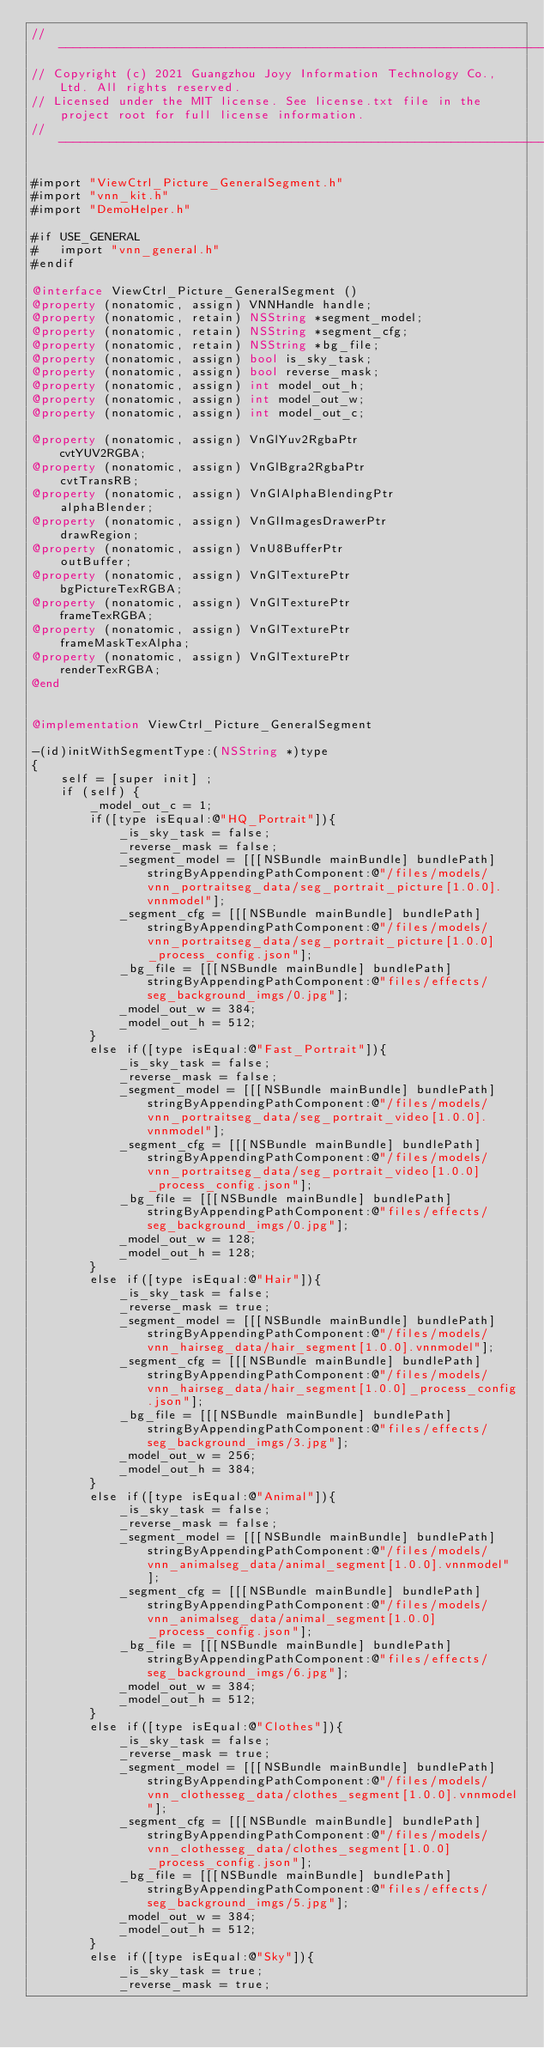<code> <loc_0><loc_0><loc_500><loc_500><_ObjectiveC_>//-------------------------------------------------------------------------------------------------------
// Copyright (c) 2021 Guangzhou Joyy Information Technology Co., Ltd. All rights reserved.
// Licensed under the MIT license. See license.txt file in the project root for full license information.
//-------------------------------------------------------------------------------------------------------

#import "ViewCtrl_Picture_GeneralSegment.h"
#import "vnn_kit.h"
#import "DemoHelper.h"

#if USE_GENERAL
#   import "vnn_general.h"
#endif

@interface ViewCtrl_Picture_GeneralSegment ()
@property (nonatomic, assign) VNNHandle handle;
@property (nonatomic, retain) NSString *segment_model;
@property (nonatomic, retain) NSString *segment_cfg;
@property (nonatomic, retain) NSString *bg_file;
@property (nonatomic, assign) bool is_sky_task;
@property (nonatomic, assign) bool reverse_mask;
@property (nonatomic, assign) int model_out_h;
@property (nonatomic, assign) int model_out_w;
@property (nonatomic, assign) int model_out_c;

@property (nonatomic, assign) VnGlYuv2RgbaPtr              cvtYUV2RGBA;
@property (nonatomic, assign) VnGlBgra2RgbaPtr             cvtTransRB;
@property (nonatomic, assign) VnGlAlphaBlendingPtr         alphaBlender;
@property (nonatomic, assign) VnGlImagesDrawerPtr          drawRegion;
@property (nonatomic, assign) VnU8BufferPtr                outBuffer;
@property (nonatomic, assign) VnGlTexturePtr               bgPictureTexRGBA;
@property (nonatomic, assign) VnGlTexturePtr               frameTexRGBA;
@property (nonatomic, assign) VnGlTexturePtr               frameMaskTexAlpha;
@property (nonatomic, assign) VnGlTexturePtr               renderTexRGBA;
@end


@implementation ViewCtrl_Picture_GeneralSegment

-(id)initWithSegmentType:(NSString *)type
{
    self = [super init] ;
    if (self) {
        _model_out_c = 1;
        if([type isEqual:@"HQ_Portrait"]){
            _is_sky_task = false;
            _reverse_mask = false;
            _segment_model = [[[NSBundle mainBundle] bundlePath] stringByAppendingPathComponent:@"/files/models/vnn_portraitseg_data/seg_portrait_picture[1.0.0].vnnmodel"];
            _segment_cfg = [[[NSBundle mainBundle] bundlePath] stringByAppendingPathComponent:@"/files/models/vnn_portraitseg_data/seg_portrait_picture[1.0.0]_process_config.json"];
            _bg_file = [[[NSBundle mainBundle] bundlePath] stringByAppendingPathComponent:@"files/effects/seg_background_imgs/0.jpg"];
            _model_out_w = 384;
            _model_out_h = 512;
        }
        else if([type isEqual:@"Fast_Portrait"]){
            _is_sky_task = false;
            _reverse_mask = false;
            _segment_model = [[[NSBundle mainBundle] bundlePath] stringByAppendingPathComponent:@"/files/models/vnn_portraitseg_data/seg_portrait_video[1.0.0].vnnmodel"];
            _segment_cfg = [[[NSBundle mainBundle] bundlePath] stringByAppendingPathComponent:@"/files/models/vnn_portraitseg_data/seg_portrait_video[1.0.0]_process_config.json"];
            _bg_file = [[[NSBundle mainBundle] bundlePath] stringByAppendingPathComponent:@"files/effects/seg_background_imgs/0.jpg"];
            _model_out_w = 128;
            _model_out_h = 128;
        }
        else if([type isEqual:@"Hair"]){
            _is_sky_task = false;
            _reverse_mask = true;
            _segment_model = [[[NSBundle mainBundle] bundlePath] stringByAppendingPathComponent:@"/files/models/vnn_hairseg_data/hair_segment[1.0.0].vnnmodel"];
            _segment_cfg = [[[NSBundle mainBundle] bundlePath] stringByAppendingPathComponent:@"/files/models/vnn_hairseg_data/hair_segment[1.0.0]_process_config.json"];
            _bg_file = [[[NSBundle mainBundle] bundlePath] stringByAppendingPathComponent:@"files/effects/seg_background_imgs/3.jpg"];
            _model_out_w = 256;
            _model_out_h = 384;
        }
        else if([type isEqual:@"Animal"]){
            _is_sky_task = false;
            _reverse_mask = false;
            _segment_model = [[[NSBundle mainBundle] bundlePath] stringByAppendingPathComponent:@"/files/models/vnn_animalseg_data/animal_segment[1.0.0].vnnmodel"];
            _segment_cfg = [[[NSBundle mainBundle] bundlePath] stringByAppendingPathComponent:@"/files/models/vnn_animalseg_data/animal_segment[1.0.0]_process_config.json"];
            _bg_file = [[[NSBundle mainBundle] bundlePath] stringByAppendingPathComponent:@"files/effects/seg_background_imgs/6.jpg"];
            _model_out_w = 384;
            _model_out_h = 512;
        }
        else if([type isEqual:@"Clothes"]){
            _is_sky_task = false;
            _reverse_mask = true;
            _segment_model = [[[NSBundle mainBundle] bundlePath] stringByAppendingPathComponent:@"/files/models/vnn_clothesseg_data/clothes_segment[1.0.0].vnnmodel"];
            _segment_cfg = [[[NSBundle mainBundle] bundlePath] stringByAppendingPathComponent:@"/files/models/vnn_clothesseg_data/clothes_segment[1.0.0]_process_config.json"];
            _bg_file = [[[NSBundle mainBundle] bundlePath] stringByAppendingPathComponent:@"files/effects/seg_background_imgs/5.jpg"];
            _model_out_w = 384;
            _model_out_h = 512;
        }
        else if([type isEqual:@"Sky"]){
            _is_sky_task = true;
            _reverse_mask = true;</code> 